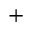<formula> <loc_0><loc_0><loc_500><loc_500>^ { + }</formula> 